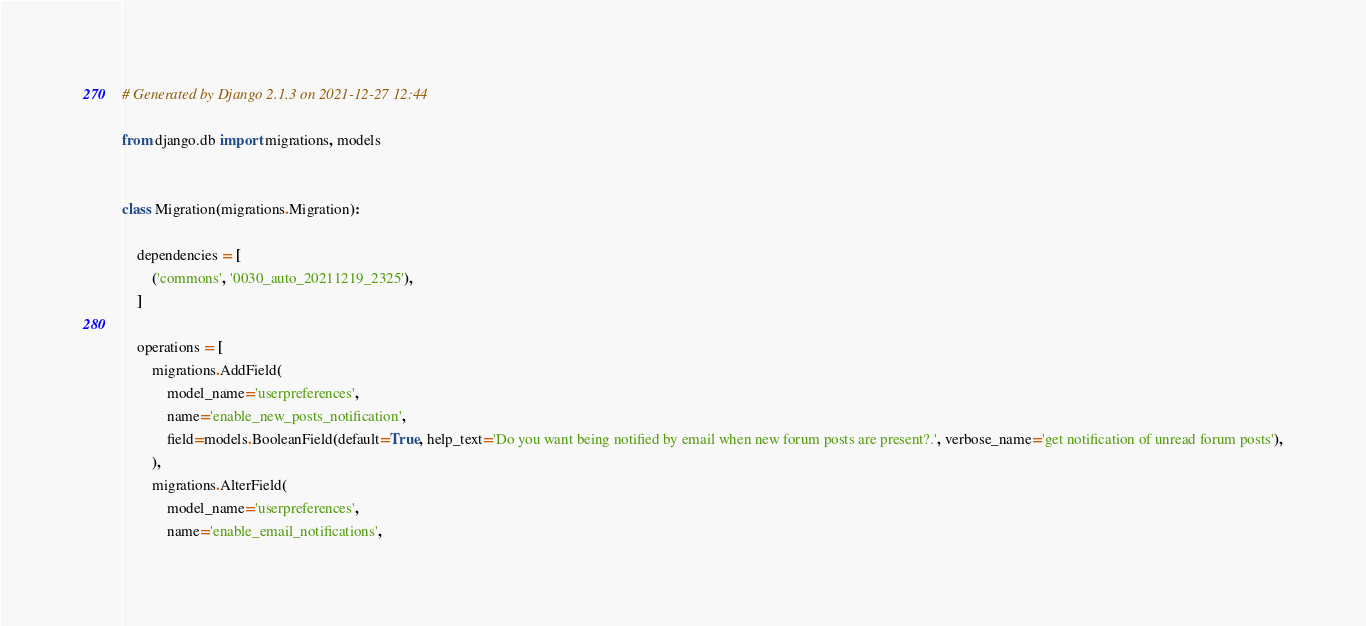<code> <loc_0><loc_0><loc_500><loc_500><_Python_># Generated by Django 2.1.3 on 2021-12-27 12:44

from django.db import migrations, models


class Migration(migrations.Migration):

    dependencies = [
        ('commons', '0030_auto_20211219_2325'),
    ]

    operations = [
        migrations.AddField(
            model_name='userpreferences',
            name='enable_new_posts_notification',
            field=models.BooleanField(default=True, help_text='Do you want being notified by email when new forum posts are present?.', verbose_name='get notification of unread forum posts'),
        ),
        migrations.AlterField(
            model_name='userpreferences',
            name='enable_email_notifications',</code> 